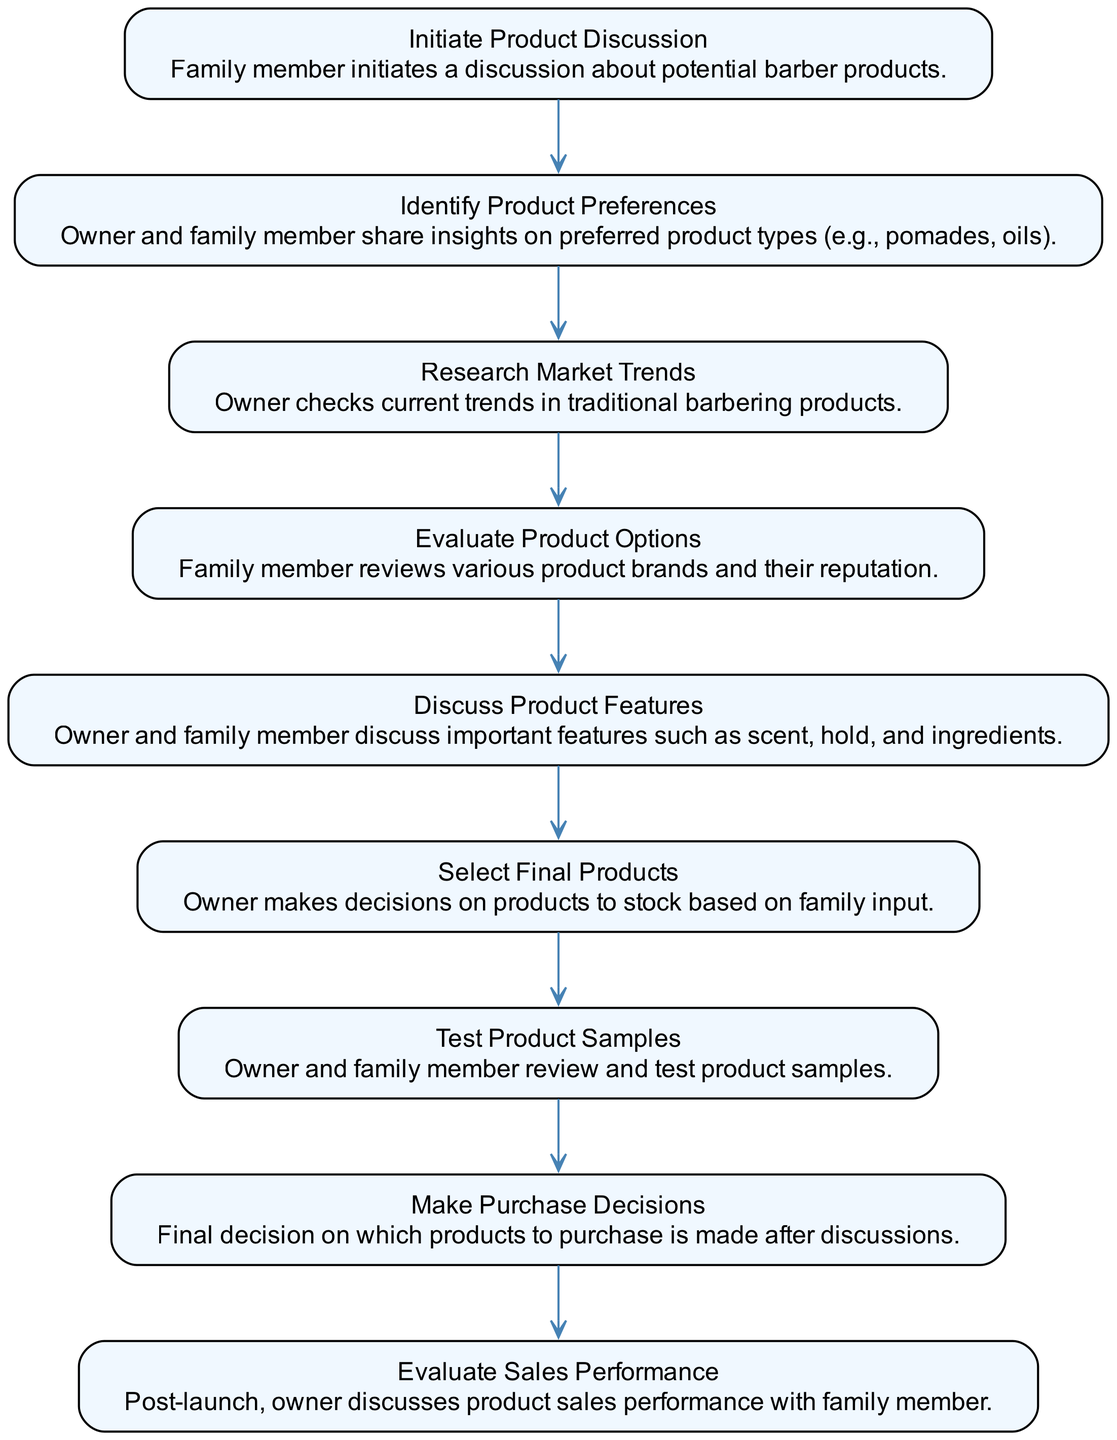What is the first step in the product selection process? The first step is "Initiate Product Discussion," where the family member starts a discussion about potential barber products.
Answer: Initiate Product Discussion How many nodes are in the diagram? There are 9 nodes in total, representing different steps in the product selection process.
Answer: 9 What step follows "Research Market Trends"? The step that follows "Research Market Trends" is "Evaluate Product Options."
Answer: Evaluate Product Options What do the owner and family member discuss after identifying product preferences? After identifying product preferences, they discuss "Product Features."
Answer: Product Features Which step involves reviewing product samples? The step that involves reviewing product samples is "Test Product Samples."
Answer: Test Product Samples What is the last action taken in the process? The last action taken in the process is "Evaluate Sales Performance."
Answer: Evaluate Sales Performance How does the "Make Purchase Decisions" step relate to "Select Final Products"? The "Make Purchase Decisions" step occurs after "Select Final Products," as it involves finalizing the decision based on family input about selected products.
Answer: After Which step follows the "Discuss Product Features"? The step that follows "Discuss Product Features" is "Select Final Products."
Answer: Select Final Products What is the primary focus of the "Evaluate Sales Performance" step? The primary focus of the "Evaluate Sales Performance" step is discussing the product sales performance with the family member post-launch.
Answer: Product sales performance 